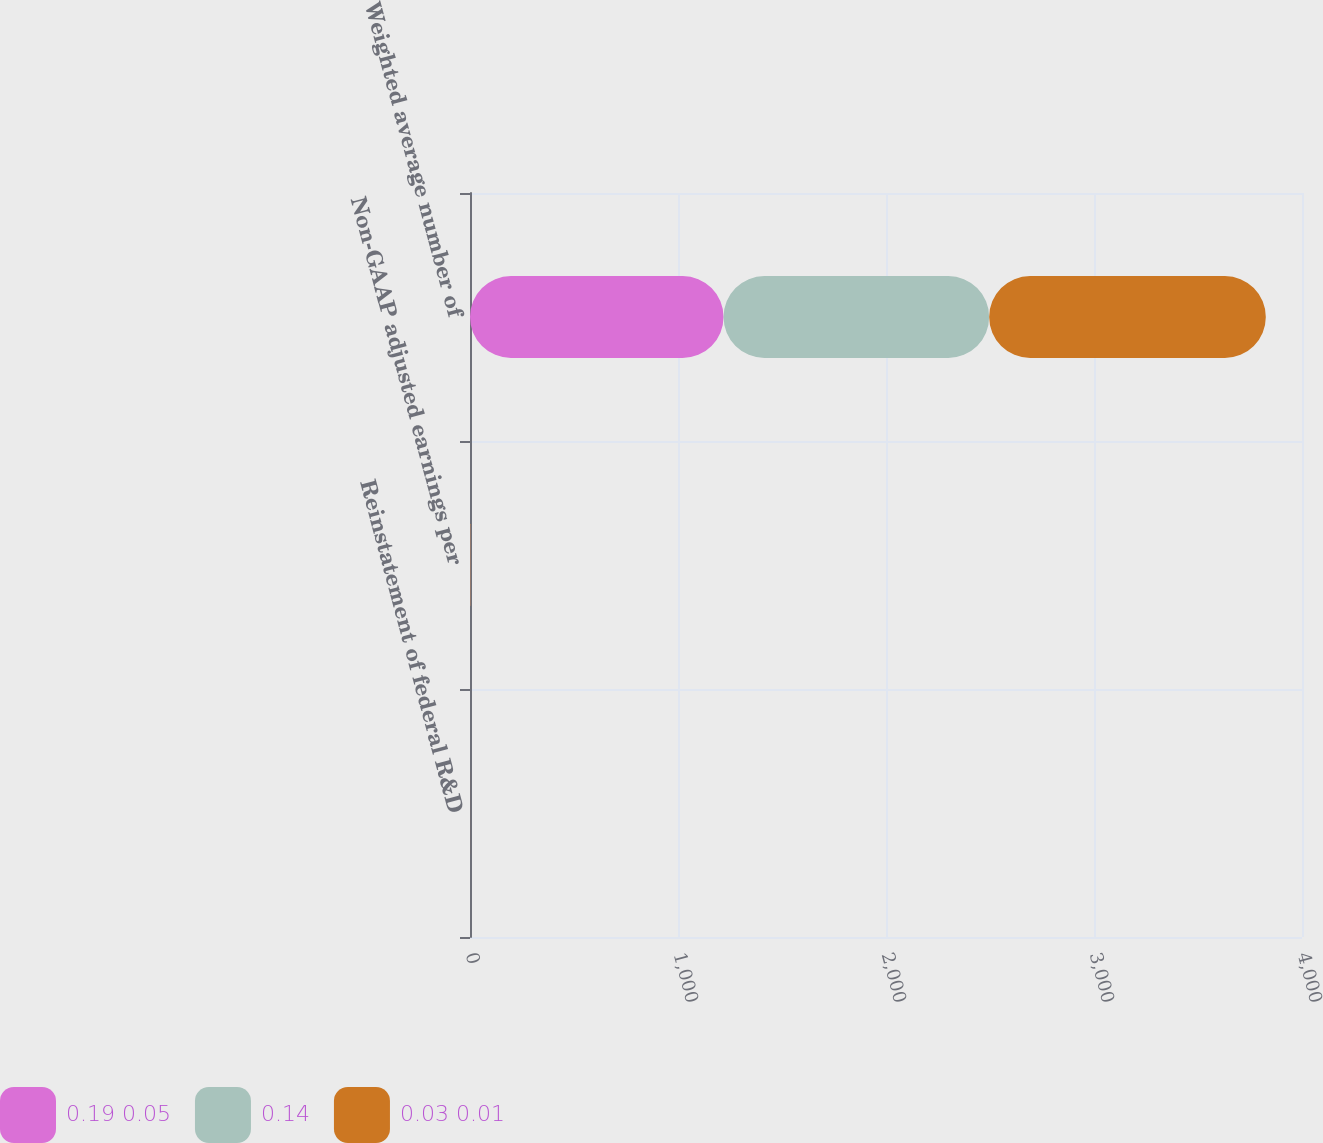Convert chart to OTSL. <chart><loc_0><loc_0><loc_500><loc_500><stacked_bar_chart><ecel><fcel>Reinstatement of federal R&D<fcel>Non-GAAP adjusted earnings per<fcel>Weighted average number of<nl><fcel>0.19 0.05<fcel>0.03<fcel>0.59<fcel>1219<nl><fcel>0.14<fcel>0.02<fcel>0.75<fcel>1277<nl><fcel>0.03 0.01<fcel>0.16<fcel>1.29<fcel>1330<nl></chart> 